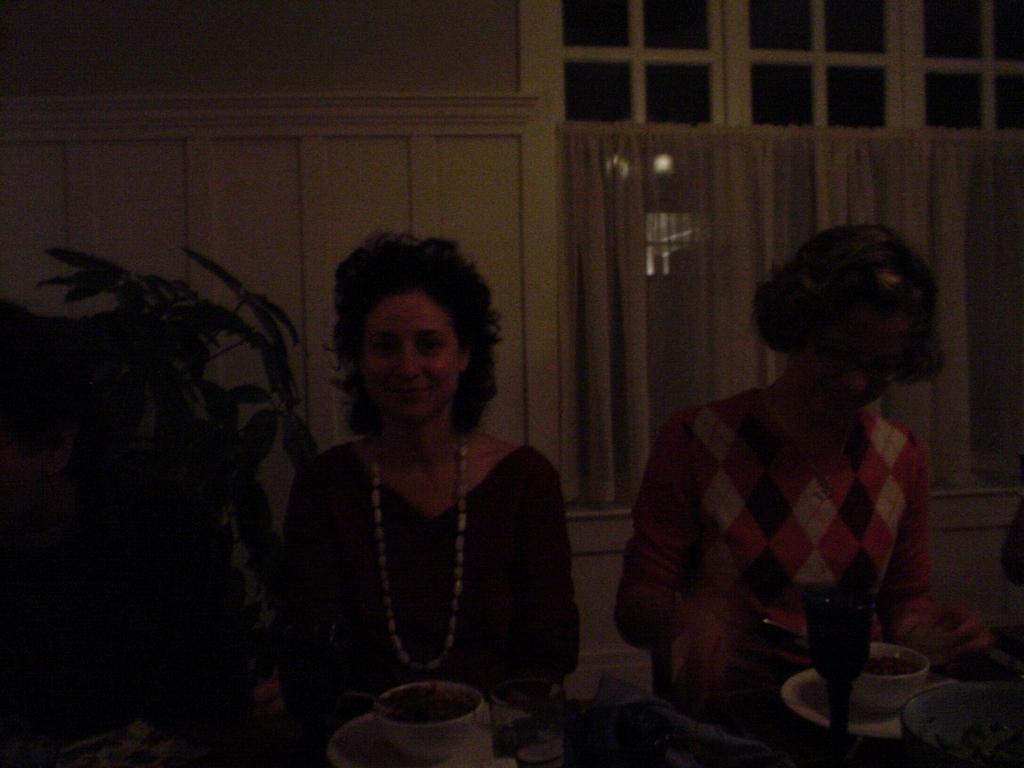How would you summarize this image in a sentence or two? In the center of the image two ladies are sitting. At the bottom of the image there is a table. On the table we can see glass, plate, bowl of food items with spoons. On the left side of the image a plant is there. In the background of the image we can see wall, curtain. 